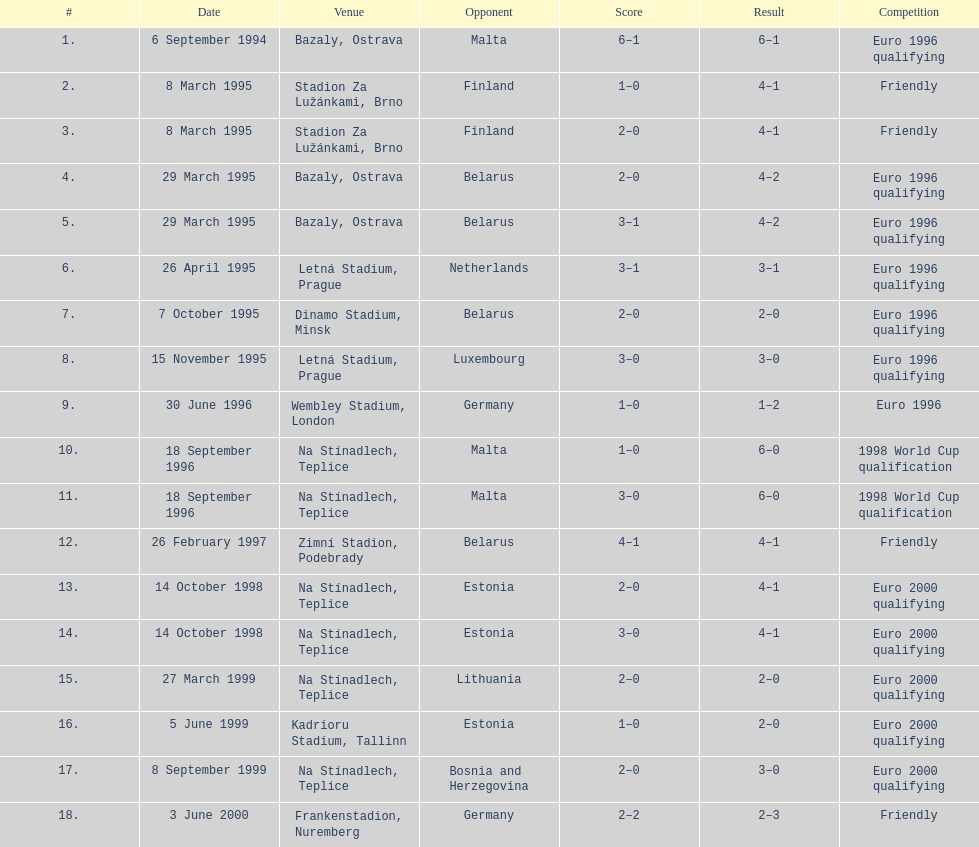List the opponents which are under the friendly competition. Finland, Belarus, Germany. 